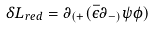Convert formula to latex. <formula><loc_0><loc_0><loc_500><loc_500>\delta L _ { r e d } = \partial _ { ( + } ( \bar { \epsilon } \partial _ { - ) } \psi \phi )</formula> 